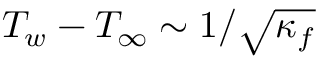Convert formula to latex. <formula><loc_0><loc_0><loc_500><loc_500>T _ { w } - T _ { \infty } \sim 1 / \sqrt { \kappa _ { f } }</formula> 